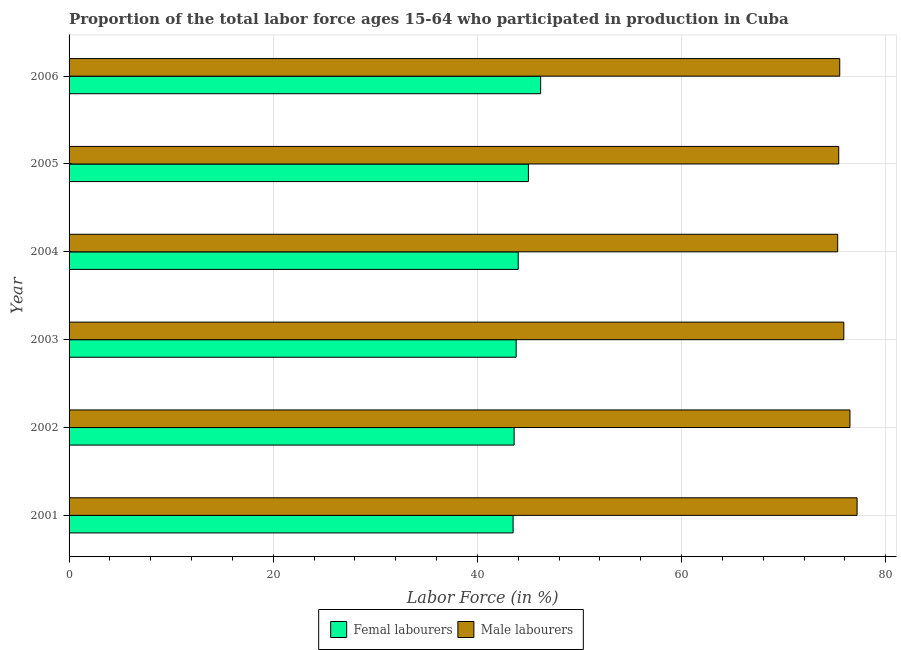How many different coloured bars are there?
Your response must be concise. 2. Are the number of bars on each tick of the Y-axis equal?
Ensure brevity in your answer.  Yes. How many bars are there on the 2nd tick from the top?
Keep it short and to the point. 2. How many bars are there on the 3rd tick from the bottom?
Provide a short and direct response. 2. What is the percentage of female labor force in 2004?
Your response must be concise. 44. Across all years, what is the maximum percentage of female labor force?
Provide a short and direct response. 46.2. Across all years, what is the minimum percentage of male labour force?
Make the answer very short. 75.3. What is the total percentage of female labor force in the graph?
Your answer should be very brief. 266.1. What is the difference between the percentage of male labour force in 2002 and that in 2005?
Provide a succinct answer. 1.1. What is the difference between the percentage of female labor force in 2004 and the percentage of male labour force in 2006?
Your response must be concise. -31.5. What is the average percentage of female labor force per year?
Ensure brevity in your answer.  44.35. In the year 2001, what is the difference between the percentage of male labour force and percentage of female labor force?
Ensure brevity in your answer.  33.7. In how many years, is the percentage of male labour force greater than 72 %?
Offer a terse response. 6. What is the ratio of the percentage of male labour force in 2002 to that in 2005?
Offer a very short reply. 1.01. Is the percentage of male labour force in 2003 less than that in 2005?
Your answer should be very brief. No. What is the difference between the highest and the second highest percentage of male labour force?
Offer a very short reply. 0.7. What is the difference between the highest and the lowest percentage of male labour force?
Keep it short and to the point. 1.9. In how many years, is the percentage of female labor force greater than the average percentage of female labor force taken over all years?
Give a very brief answer. 2. What does the 2nd bar from the top in 2002 represents?
Offer a very short reply. Femal labourers. What does the 2nd bar from the bottom in 2006 represents?
Ensure brevity in your answer.  Male labourers. Are all the bars in the graph horizontal?
Keep it short and to the point. Yes. How many years are there in the graph?
Ensure brevity in your answer.  6. What is the difference between two consecutive major ticks on the X-axis?
Give a very brief answer. 20. Where does the legend appear in the graph?
Offer a very short reply. Bottom center. How many legend labels are there?
Give a very brief answer. 2. How are the legend labels stacked?
Offer a very short reply. Horizontal. What is the title of the graph?
Ensure brevity in your answer.  Proportion of the total labor force ages 15-64 who participated in production in Cuba. What is the label or title of the X-axis?
Your answer should be very brief. Labor Force (in %). What is the label or title of the Y-axis?
Offer a very short reply. Year. What is the Labor Force (in %) of Femal labourers in 2001?
Provide a short and direct response. 43.5. What is the Labor Force (in %) in Male labourers in 2001?
Ensure brevity in your answer.  77.2. What is the Labor Force (in %) in Femal labourers in 2002?
Your response must be concise. 43.6. What is the Labor Force (in %) of Male labourers in 2002?
Offer a terse response. 76.5. What is the Labor Force (in %) of Femal labourers in 2003?
Provide a succinct answer. 43.8. What is the Labor Force (in %) in Male labourers in 2003?
Provide a short and direct response. 75.9. What is the Labor Force (in %) in Femal labourers in 2004?
Provide a succinct answer. 44. What is the Labor Force (in %) of Male labourers in 2004?
Provide a succinct answer. 75.3. What is the Labor Force (in %) of Male labourers in 2005?
Provide a succinct answer. 75.4. What is the Labor Force (in %) of Femal labourers in 2006?
Give a very brief answer. 46.2. What is the Labor Force (in %) in Male labourers in 2006?
Make the answer very short. 75.5. Across all years, what is the maximum Labor Force (in %) of Femal labourers?
Your response must be concise. 46.2. Across all years, what is the maximum Labor Force (in %) in Male labourers?
Your response must be concise. 77.2. Across all years, what is the minimum Labor Force (in %) in Femal labourers?
Your response must be concise. 43.5. Across all years, what is the minimum Labor Force (in %) in Male labourers?
Keep it short and to the point. 75.3. What is the total Labor Force (in %) of Femal labourers in the graph?
Make the answer very short. 266.1. What is the total Labor Force (in %) in Male labourers in the graph?
Your response must be concise. 455.8. What is the difference between the Labor Force (in %) in Femal labourers in 2001 and that in 2002?
Your answer should be compact. -0.1. What is the difference between the Labor Force (in %) in Femal labourers in 2001 and that in 2003?
Your answer should be very brief. -0.3. What is the difference between the Labor Force (in %) of Femal labourers in 2001 and that in 2004?
Give a very brief answer. -0.5. What is the difference between the Labor Force (in %) of Male labourers in 2001 and that in 2005?
Ensure brevity in your answer.  1.8. What is the difference between the Labor Force (in %) of Femal labourers in 2001 and that in 2006?
Offer a terse response. -2.7. What is the difference between the Labor Force (in %) of Male labourers in 2001 and that in 2006?
Make the answer very short. 1.7. What is the difference between the Labor Force (in %) in Femal labourers in 2002 and that in 2003?
Offer a very short reply. -0.2. What is the difference between the Labor Force (in %) of Male labourers in 2002 and that in 2003?
Keep it short and to the point. 0.6. What is the difference between the Labor Force (in %) of Male labourers in 2002 and that in 2004?
Provide a succinct answer. 1.2. What is the difference between the Labor Force (in %) of Femal labourers in 2002 and that in 2005?
Provide a succinct answer. -1.4. What is the difference between the Labor Force (in %) of Male labourers in 2002 and that in 2006?
Keep it short and to the point. 1. What is the difference between the Labor Force (in %) of Femal labourers in 2003 and that in 2004?
Your answer should be compact. -0.2. What is the difference between the Labor Force (in %) of Male labourers in 2003 and that in 2004?
Offer a terse response. 0.6. What is the difference between the Labor Force (in %) in Male labourers in 2003 and that in 2005?
Your answer should be very brief. 0.5. What is the difference between the Labor Force (in %) of Male labourers in 2003 and that in 2006?
Provide a short and direct response. 0.4. What is the difference between the Labor Force (in %) in Femal labourers in 2004 and that in 2005?
Offer a terse response. -1. What is the difference between the Labor Force (in %) in Femal labourers in 2001 and the Labor Force (in %) in Male labourers in 2002?
Ensure brevity in your answer.  -33. What is the difference between the Labor Force (in %) in Femal labourers in 2001 and the Labor Force (in %) in Male labourers in 2003?
Offer a terse response. -32.4. What is the difference between the Labor Force (in %) of Femal labourers in 2001 and the Labor Force (in %) of Male labourers in 2004?
Your answer should be very brief. -31.8. What is the difference between the Labor Force (in %) of Femal labourers in 2001 and the Labor Force (in %) of Male labourers in 2005?
Your answer should be compact. -31.9. What is the difference between the Labor Force (in %) in Femal labourers in 2001 and the Labor Force (in %) in Male labourers in 2006?
Your answer should be compact. -32. What is the difference between the Labor Force (in %) in Femal labourers in 2002 and the Labor Force (in %) in Male labourers in 2003?
Your response must be concise. -32.3. What is the difference between the Labor Force (in %) in Femal labourers in 2002 and the Labor Force (in %) in Male labourers in 2004?
Give a very brief answer. -31.7. What is the difference between the Labor Force (in %) of Femal labourers in 2002 and the Labor Force (in %) of Male labourers in 2005?
Provide a short and direct response. -31.8. What is the difference between the Labor Force (in %) of Femal labourers in 2002 and the Labor Force (in %) of Male labourers in 2006?
Offer a terse response. -31.9. What is the difference between the Labor Force (in %) in Femal labourers in 2003 and the Labor Force (in %) in Male labourers in 2004?
Your answer should be very brief. -31.5. What is the difference between the Labor Force (in %) in Femal labourers in 2003 and the Labor Force (in %) in Male labourers in 2005?
Your answer should be very brief. -31.6. What is the difference between the Labor Force (in %) in Femal labourers in 2003 and the Labor Force (in %) in Male labourers in 2006?
Your answer should be very brief. -31.7. What is the difference between the Labor Force (in %) in Femal labourers in 2004 and the Labor Force (in %) in Male labourers in 2005?
Keep it short and to the point. -31.4. What is the difference between the Labor Force (in %) of Femal labourers in 2004 and the Labor Force (in %) of Male labourers in 2006?
Your answer should be very brief. -31.5. What is the difference between the Labor Force (in %) in Femal labourers in 2005 and the Labor Force (in %) in Male labourers in 2006?
Offer a terse response. -30.5. What is the average Labor Force (in %) of Femal labourers per year?
Ensure brevity in your answer.  44.35. What is the average Labor Force (in %) in Male labourers per year?
Offer a very short reply. 75.97. In the year 2001, what is the difference between the Labor Force (in %) of Femal labourers and Labor Force (in %) of Male labourers?
Your answer should be very brief. -33.7. In the year 2002, what is the difference between the Labor Force (in %) of Femal labourers and Labor Force (in %) of Male labourers?
Ensure brevity in your answer.  -32.9. In the year 2003, what is the difference between the Labor Force (in %) of Femal labourers and Labor Force (in %) of Male labourers?
Ensure brevity in your answer.  -32.1. In the year 2004, what is the difference between the Labor Force (in %) of Femal labourers and Labor Force (in %) of Male labourers?
Make the answer very short. -31.3. In the year 2005, what is the difference between the Labor Force (in %) in Femal labourers and Labor Force (in %) in Male labourers?
Offer a very short reply. -30.4. In the year 2006, what is the difference between the Labor Force (in %) in Femal labourers and Labor Force (in %) in Male labourers?
Offer a terse response. -29.3. What is the ratio of the Labor Force (in %) of Male labourers in 2001 to that in 2002?
Provide a succinct answer. 1.01. What is the ratio of the Labor Force (in %) in Femal labourers in 2001 to that in 2003?
Offer a very short reply. 0.99. What is the ratio of the Labor Force (in %) in Male labourers in 2001 to that in 2003?
Your answer should be very brief. 1.02. What is the ratio of the Labor Force (in %) in Male labourers in 2001 to that in 2004?
Keep it short and to the point. 1.03. What is the ratio of the Labor Force (in %) of Femal labourers in 2001 to that in 2005?
Offer a very short reply. 0.97. What is the ratio of the Labor Force (in %) of Male labourers in 2001 to that in 2005?
Provide a short and direct response. 1.02. What is the ratio of the Labor Force (in %) of Femal labourers in 2001 to that in 2006?
Keep it short and to the point. 0.94. What is the ratio of the Labor Force (in %) in Male labourers in 2001 to that in 2006?
Your answer should be compact. 1.02. What is the ratio of the Labor Force (in %) of Male labourers in 2002 to that in 2003?
Provide a short and direct response. 1.01. What is the ratio of the Labor Force (in %) in Femal labourers in 2002 to that in 2004?
Make the answer very short. 0.99. What is the ratio of the Labor Force (in %) of Male labourers in 2002 to that in 2004?
Ensure brevity in your answer.  1.02. What is the ratio of the Labor Force (in %) of Femal labourers in 2002 to that in 2005?
Offer a very short reply. 0.97. What is the ratio of the Labor Force (in %) of Male labourers in 2002 to that in 2005?
Ensure brevity in your answer.  1.01. What is the ratio of the Labor Force (in %) of Femal labourers in 2002 to that in 2006?
Make the answer very short. 0.94. What is the ratio of the Labor Force (in %) in Male labourers in 2002 to that in 2006?
Your answer should be compact. 1.01. What is the ratio of the Labor Force (in %) of Femal labourers in 2003 to that in 2004?
Make the answer very short. 1. What is the ratio of the Labor Force (in %) in Male labourers in 2003 to that in 2004?
Your answer should be very brief. 1.01. What is the ratio of the Labor Force (in %) of Femal labourers in 2003 to that in 2005?
Give a very brief answer. 0.97. What is the ratio of the Labor Force (in %) in Male labourers in 2003 to that in 2005?
Offer a very short reply. 1.01. What is the ratio of the Labor Force (in %) of Femal labourers in 2003 to that in 2006?
Offer a terse response. 0.95. What is the ratio of the Labor Force (in %) in Femal labourers in 2004 to that in 2005?
Offer a terse response. 0.98. What is the ratio of the Labor Force (in %) of Male labourers in 2004 to that in 2006?
Provide a succinct answer. 1. What is the difference between the highest and the second highest Labor Force (in %) in Femal labourers?
Your response must be concise. 1.2. What is the difference between the highest and the lowest Labor Force (in %) of Male labourers?
Offer a very short reply. 1.9. 